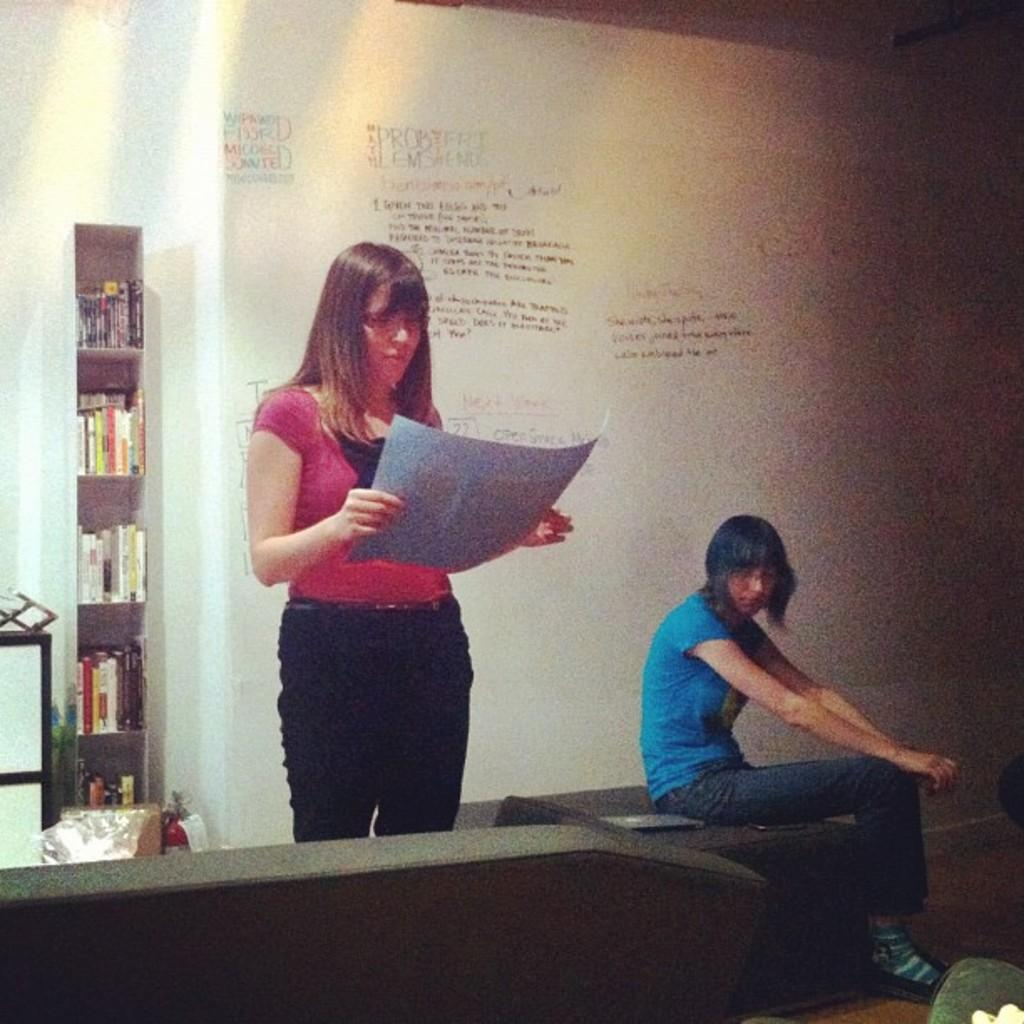How many women are in the image? There are two women in the image. What is one of the women holding? One woman is holding a paper. What is the other woman doing in the image? The other woman is sitting on a couch. What can be seen in the background of the image? Bookshelves are visible in the background. What is attached to the wall in the image? There is a board attached to the wall. Can you see any protest signs or people participating in a protest in the image? There is no indication of a protest or protest signs in the image. 